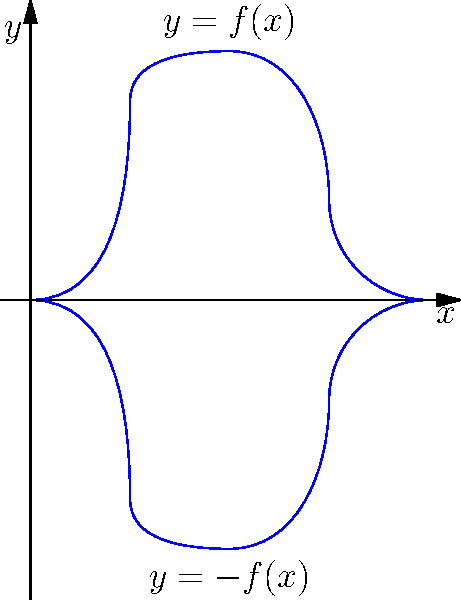As a film producer showcasing a rock star's transformation, you want to create a unique guitar-shaped trophy. The guitar's outline is modeled by the function $f(x)$ shown in the graph, where $0 \leq x \leq 4$. If the guitar is formed by rotating this curve around the x-axis, calculate the volume of the trophy using the washer method. Assume $f(x) = \sqrt{x(4-x)}$. To solve this problem, we'll use the washer method for volume calculation:

1) The washer method formula for volume is:
   $$V = \pi \int_a^b [R(x)^2 - r(x)^2] dx$$
   where $R(x)$ is the outer radius and $r(x)$ is the inner radius.

2) In this case, $R(x) = f(x) = \sqrt{x(4-x)}$ and $r(x) = 0$ (since we're rotating around the x-axis).

3) Our limits of integration are from $a=0$ to $b=4$.

4) Substituting into the formula:
   $$V = \pi \int_0^4 [\sqrt{x(4-x)}^2 - 0^2] dx$$

5) Simplify:
   $$V = \pi \int_0^4 x(4-x) dx$$

6) Expand:
   $$V = \pi \int_0^4 (4x - x^2) dx$$

7) Integrate:
   $$V = \pi [2x^2 - \frac{1}{3}x^3]_0^4$$

8) Evaluate the limits:
   $$V = \pi [(2(4^2) - \frac{1}{3}(4^3)) - (2(0^2) - \frac{1}{3}(0^3))]$$

9) Simplify:
   $$V = \pi [32 - \frac{64}{3}] = \pi [\frac{96}{3} - \frac{64}{3}] = \pi [\frac{32}{3}]$$

10) Final result:
    $$V = \frac{32\pi}{3} \approx 33.51 \text{ cubic units}$$
Answer: $\frac{32\pi}{3}$ cubic units 